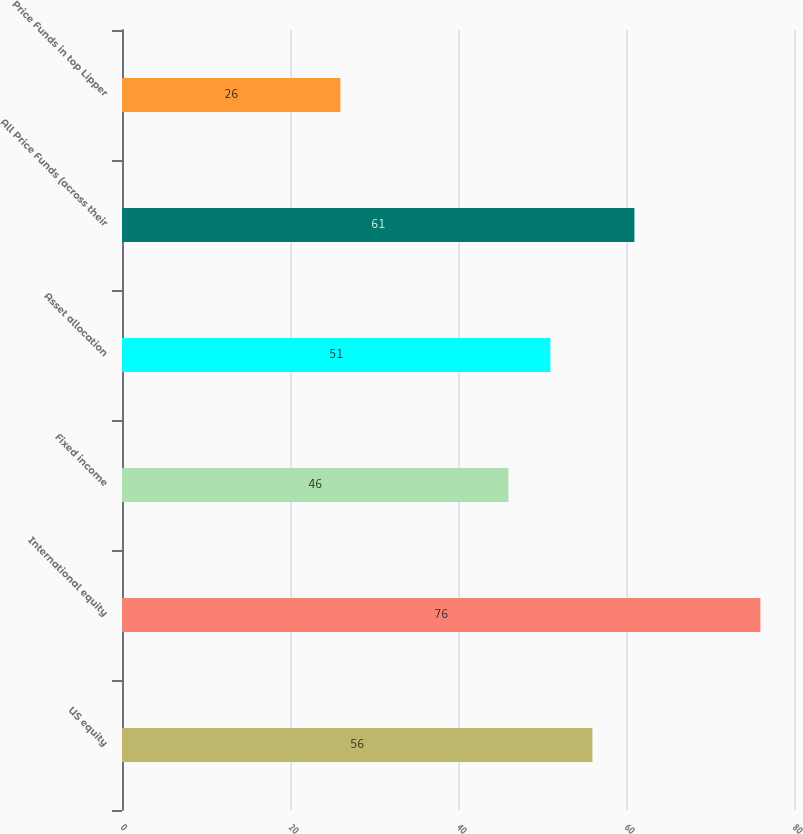<chart> <loc_0><loc_0><loc_500><loc_500><bar_chart><fcel>US equity<fcel>International equity<fcel>Fixed income<fcel>Asset allocation<fcel>All Price Funds (across their<fcel>Price Funds in top Lipper<nl><fcel>56<fcel>76<fcel>46<fcel>51<fcel>61<fcel>26<nl></chart> 